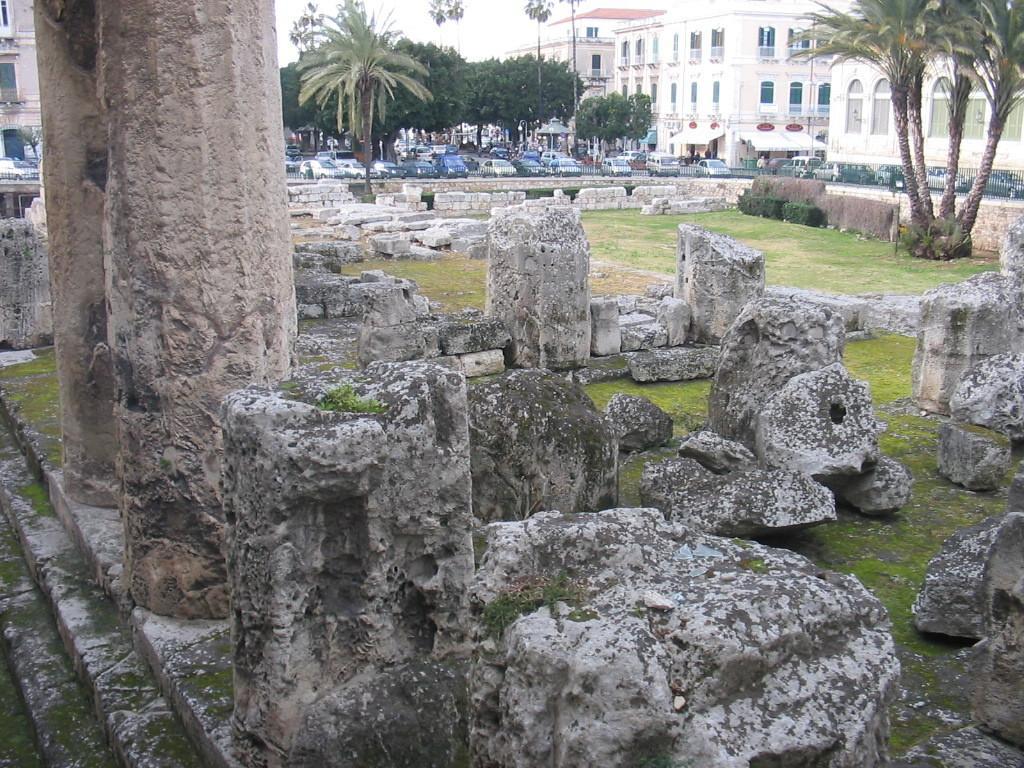Can you describe this image briefly? In the foreground of the picture I can see the rocks on the green grass. I can see two pillars and staircase on the left side. In the background, I can see the buildings, trees and cars. 